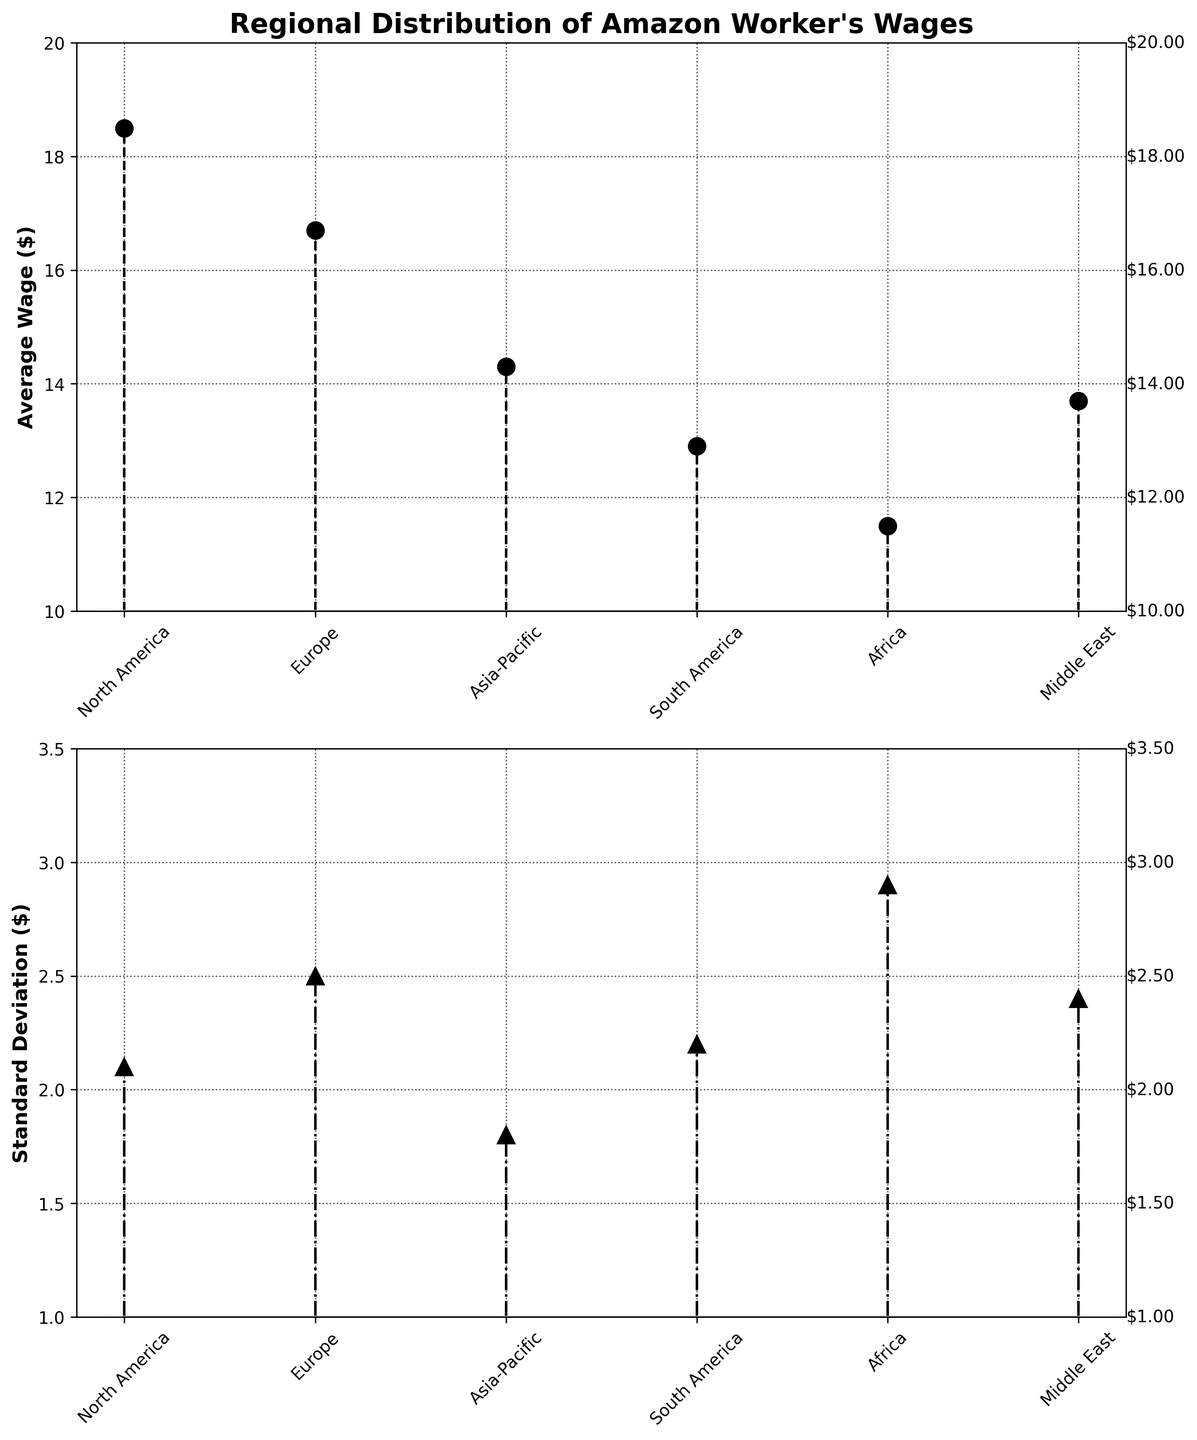How many regions are shown in the plot of average wages? Count the distinct regions on the x-axis of the average wages plot. There are six regions: North America, Europe, Asia-Pacific, South America, Africa, and Middle East.
Answer: 6 What is the tallest stem in the plot of standard deviations? Identify the tallest vertical line in the standard deviation plot and find the corresponding y-axis value. The tallest stem corresponds to Africa with a standard deviation of 2.90.
Answer: Africa, 2.9 Which region has the lowest average wage? Locate the lowest point on the y-axis of the average wages plot and identify the corresponding region. The lowest average wage is in Africa, at $11.50.
Answer: Africa What's the difference between the highest and the lowest average wages? Subtract the lowest value from the highest value on the average wages plot. The highest average wage is $18.50 (North America) and the lowest is $11.50 (Africa). Therefore, $18.50 - $11.50 = $7.00.
Answer: $7.00 How does the standard deviation for Asia-Pacific compare to that for South America? Compare the heights of the stems corresponding to Asia-Pacific and South America in the standard deviation plot. Asia-Pacific has a standard deviation of $1.80, while South America has $2.20.
Answer: Asia-Pacific is lower Which regions have a higher standard deviation than the Middle East? Compare the standard deviation values and identify regions with higher standard deviations than the Middle East, which has a value of $2.40. Both South America ($2.20) and Africa ($2.90) fall into this category.
Answer: Africa What is the range of standard deviations for all regions? Identify the minimum and maximum standard deviation values (y-axis) then subtract the minimum from the maximum. The minimum standard deviation is $1.80 (Asia-Pacific), and the maximum is $2.90 (Africa). Therefore, $2.90 - $1.80 = $1.10.
Answer: $1.10 